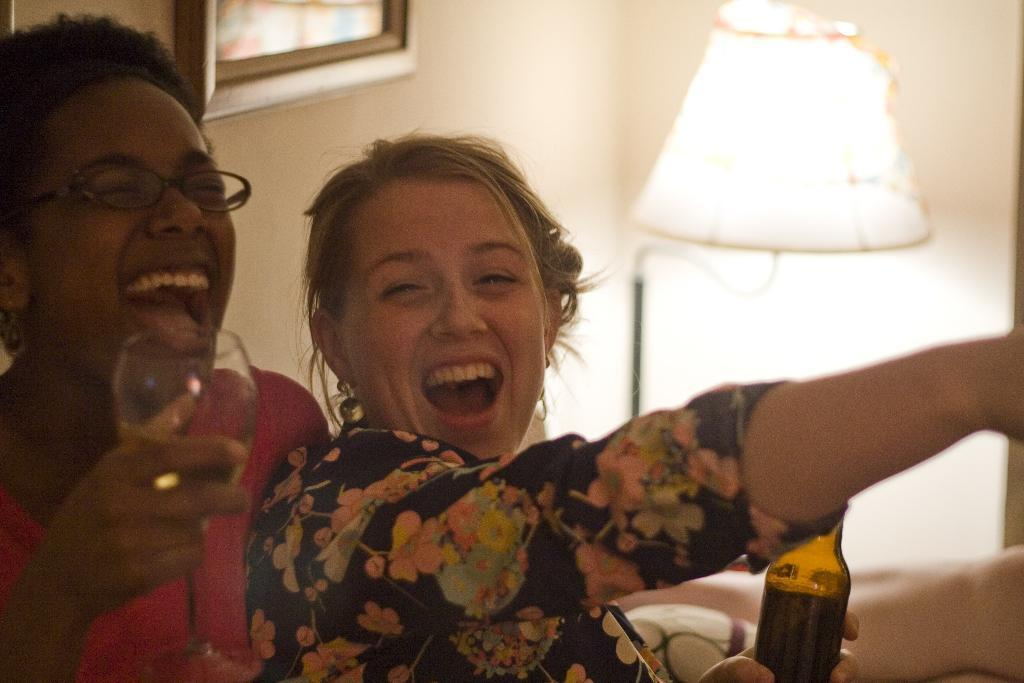How many people are in the image? There are two ladies in the image. What are the ladies holding in their hands? The ladies are holding a glass and a bottle. What can be seen in the background of the image? There is a photo frame and a lamp in the background of the image. Where is the throne located in the image? There is no throne present in the image. What type of plate is being used by the ladies in the image? The ladies are not using a plate in the image; they are holding a glass and a bottle. 